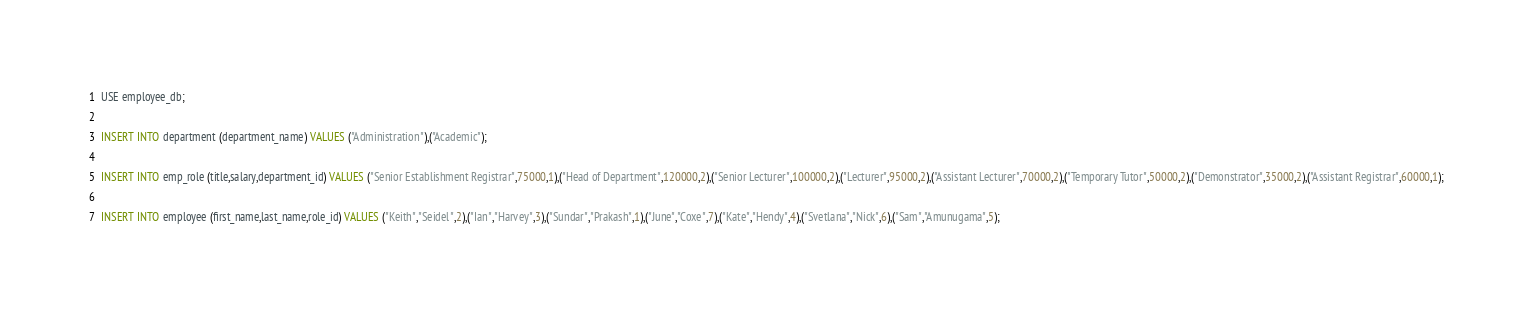<code> <loc_0><loc_0><loc_500><loc_500><_SQL_>USE employee_db;

INSERT INTO department (department_name) VALUES ("Administration"),("Academic");

INSERT INTO emp_role (title,salary,department_id) VALUES ("Senior Establishment Registrar",75000,1),("Head of Department",120000,2),("Senior Lecturer",100000,2),("Lecturer",95000,2),("Assistant Lecturer",70000,2),("Temporary Tutor",50000,2),("Demonstrator",35000,2),("Assistant Registrar",60000,1);

INSERT INTO employee (first_name,last_name,role_id) VALUES ("Keith","Seidel",2),("Ian","Harvey",3),("Sundar","Prakash",1),("June","Coxe",7),("Kate","Hendy",4),("Svetlana","Nick",6),("Sam","Amunugama",5);</code> 